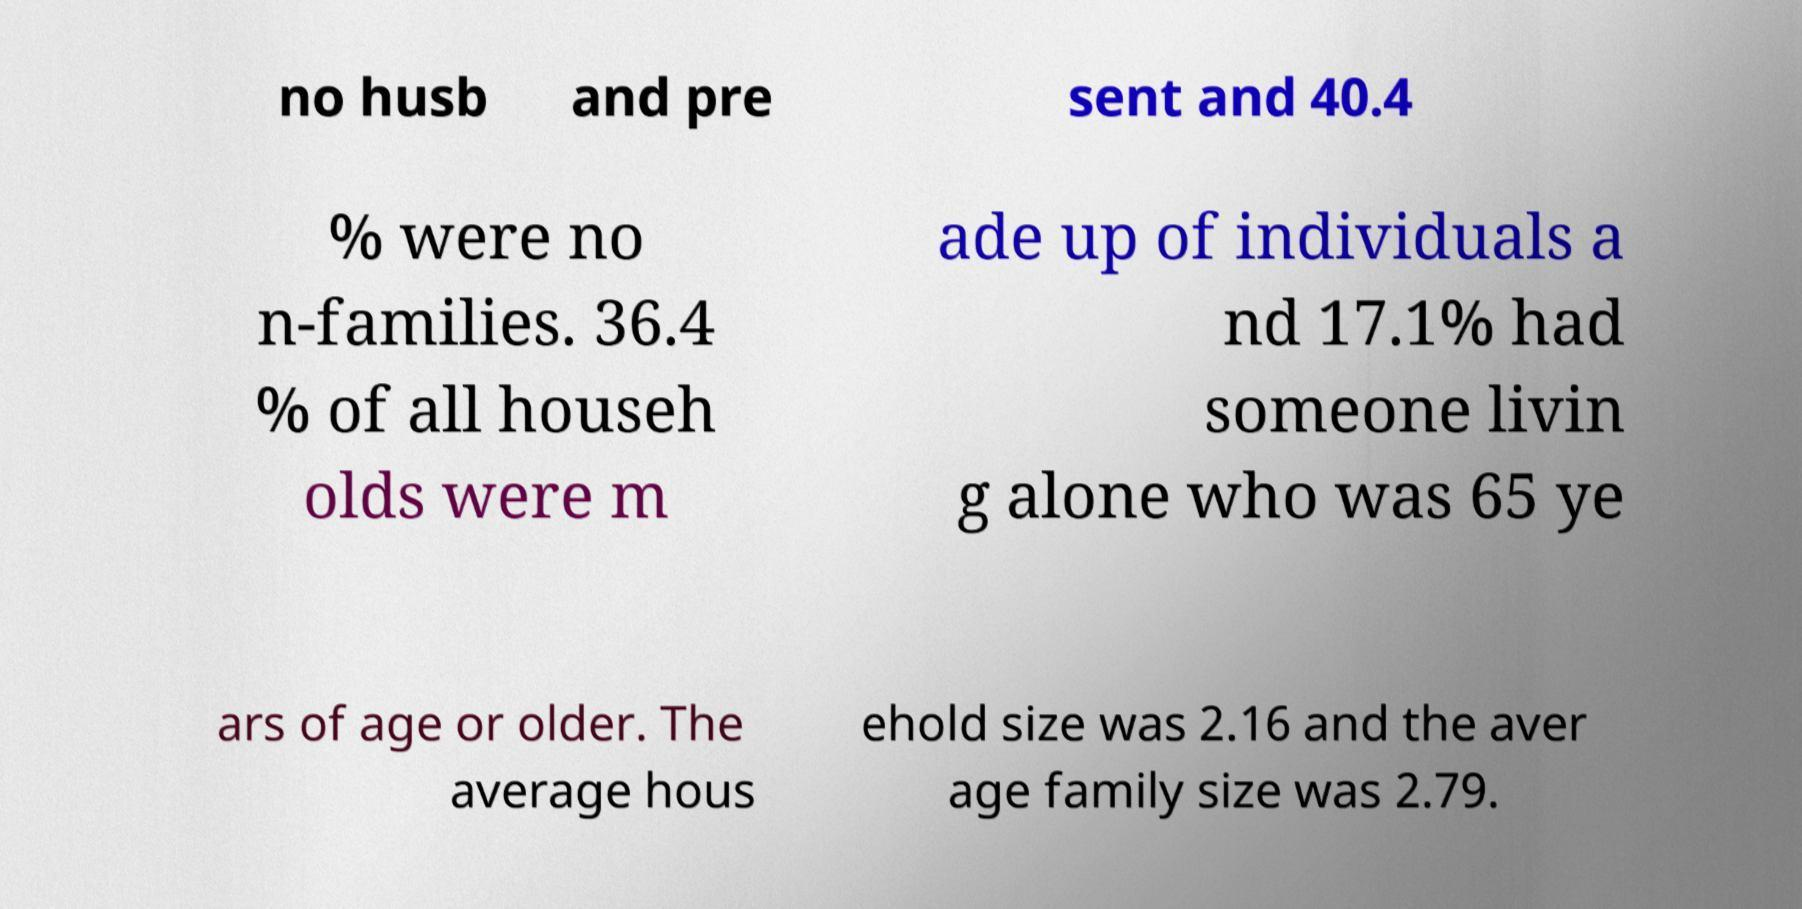Can you accurately transcribe the text from the provided image for me? no husb and pre sent and 40.4 % were no n-families. 36.4 % of all househ olds were m ade up of individuals a nd 17.1% had someone livin g alone who was 65 ye ars of age or older. The average hous ehold size was 2.16 and the aver age family size was 2.79. 